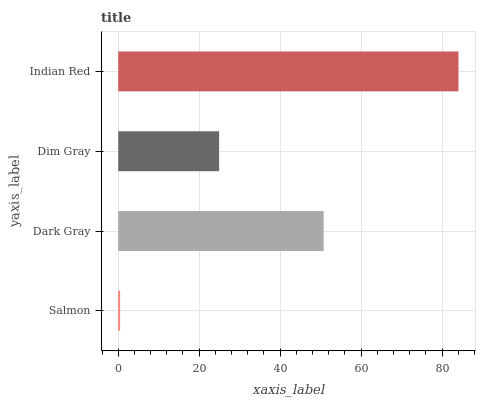Is Salmon the minimum?
Answer yes or no. Yes. Is Indian Red the maximum?
Answer yes or no. Yes. Is Dark Gray the minimum?
Answer yes or no. No. Is Dark Gray the maximum?
Answer yes or no. No. Is Dark Gray greater than Salmon?
Answer yes or no. Yes. Is Salmon less than Dark Gray?
Answer yes or no. Yes. Is Salmon greater than Dark Gray?
Answer yes or no. No. Is Dark Gray less than Salmon?
Answer yes or no. No. Is Dark Gray the high median?
Answer yes or no. Yes. Is Dim Gray the low median?
Answer yes or no. Yes. Is Indian Red the high median?
Answer yes or no. No. Is Salmon the low median?
Answer yes or no. No. 